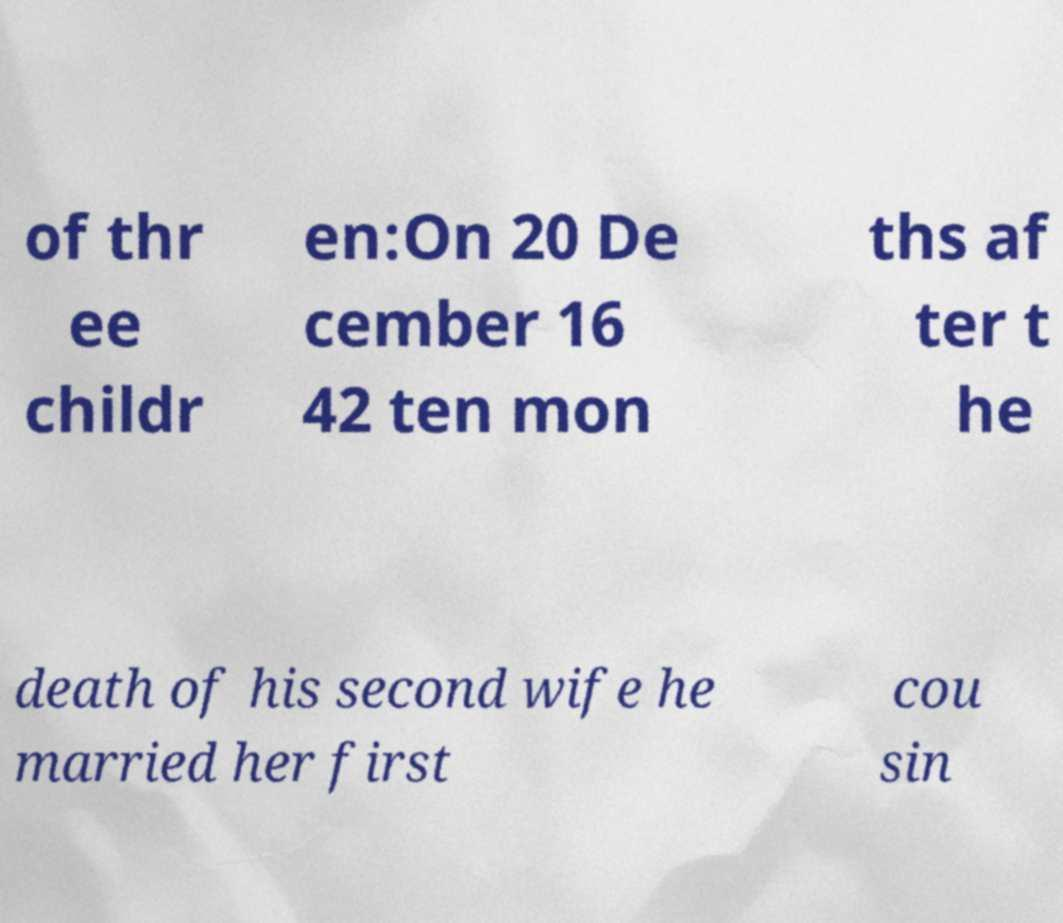Could you extract and type out the text from this image? of thr ee childr en:On 20 De cember 16 42 ten mon ths af ter t he death of his second wife he married her first cou sin 